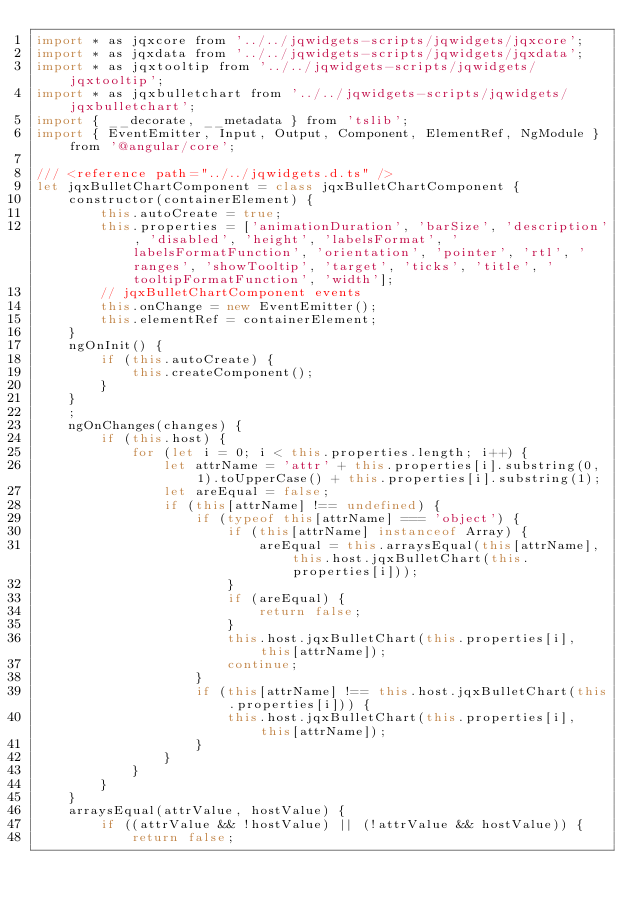<code> <loc_0><loc_0><loc_500><loc_500><_JavaScript_>import * as jqxcore from '../../jqwidgets-scripts/jqwidgets/jqxcore';
import * as jqxdata from '../../jqwidgets-scripts/jqwidgets/jqxdata';
import * as jqxtooltip from '../../jqwidgets-scripts/jqwidgets/jqxtooltip';
import * as jqxbulletchart from '../../jqwidgets-scripts/jqwidgets/jqxbulletchart';
import { __decorate, __metadata } from 'tslib';
import { EventEmitter, Input, Output, Component, ElementRef, NgModule } from '@angular/core';

/// <reference path="../../jqwidgets.d.ts" />
let jqxBulletChartComponent = class jqxBulletChartComponent {
    constructor(containerElement) {
        this.autoCreate = true;
        this.properties = ['animationDuration', 'barSize', 'description', 'disabled', 'height', 'labelsFormat', 'labelsFormatFunction', 'orientation', 'pointer', 'rtl', 'ranges', 'showTooltip', 'target', 'ticks', 'title', 'tooltipFormatFunction', 'width'];
        // jqxBulletChartComponent events
        this.onChange = new EventEmitter();
        this.elementRef = containerElement;
    }
    ngOnInit() {
        if (this.autoCreate) {
            this.createComponent();
        }
    }
    ;
    ngOnChanges(changes) {
        if (this.host) {
            for (let i = 0; i < this.properties.length; i++) {
                let attrName = 'attr' + this.properties[i].substring(0, 1).toUpperCase() + this.properties[i].substring(1);
                let areEqual = false;
                if (this[attrName] !== undefined) {
                    if (typeof this[attrName] === 'object') {
                        if (this[attrName] instanceof Array) {
                            areEqual = this.arraysEqual(this[attrName], this.host.jqxBulletChart(this.properties[i]));
                        }
                        if (areEqual) {
                            return false;
                        }
                        this.host.jqxBulletChart(this.properties[i], this[attrName]);
                        continue;
                    }
                    if (this[attrName] !== this.host.jqxBulletChart(this.properties[i])) {
                        this.host.jqxBulletChart(this.properties[i], this[attrName]);
                    }
                }
            }
        }
    }
    arraysEqual(attrValue, hostValue) {
        if ((attrValue && !hostValue) || (!attrValue && hostValue)) {
            return false;</code> 